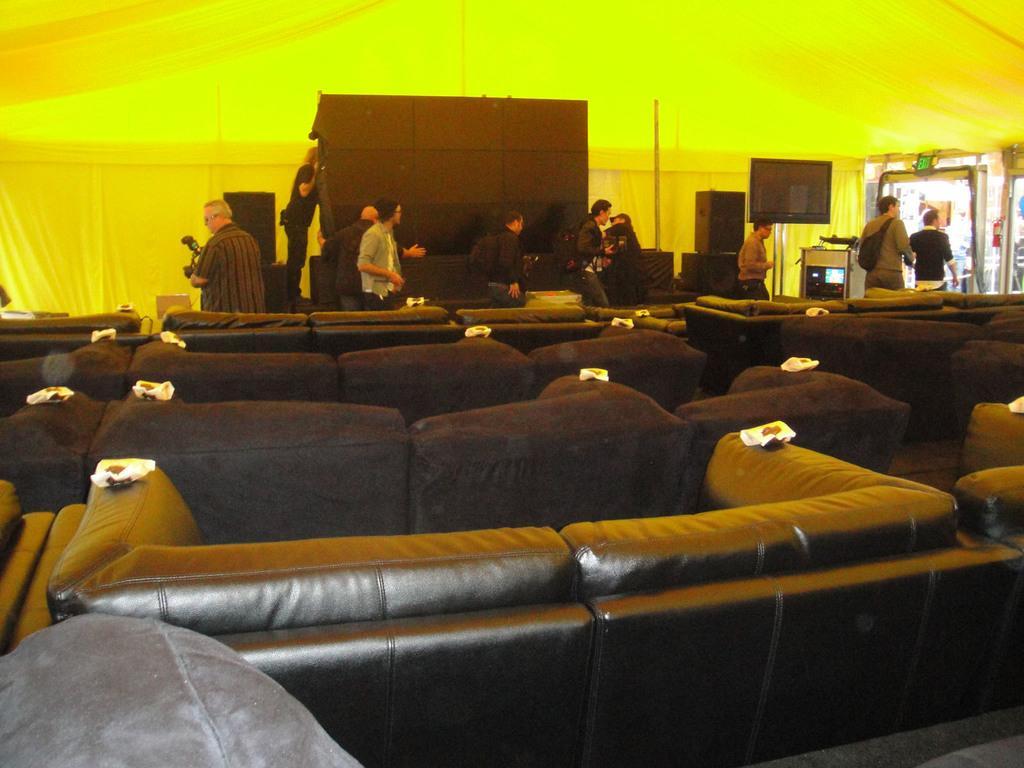Can you describe this image briefly? In the image there are many sofas in the front and in the back there is a black screen with speakers on either side and many people walking in front of it and above its tent. 